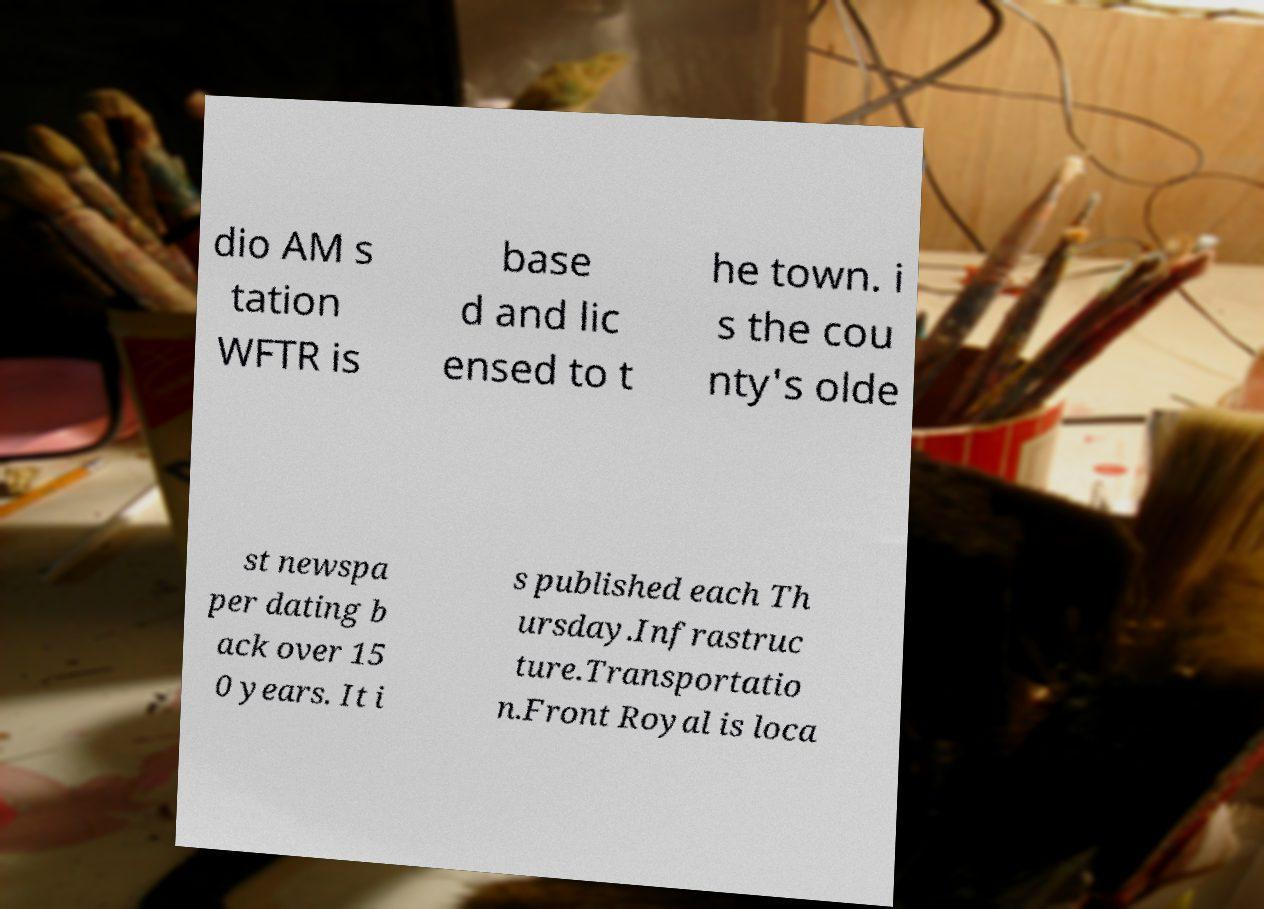What messages or text are displayed in this image? I need them in a readable, typed format. dio AM s tation WFTR is base d and lic ensed to t he town. i s the cou nty's olde st newspa per dating b ack over 15 0 years. It i s published each Th ursday.Infrastruc ture.Transportatio n.Front Royal is loca 